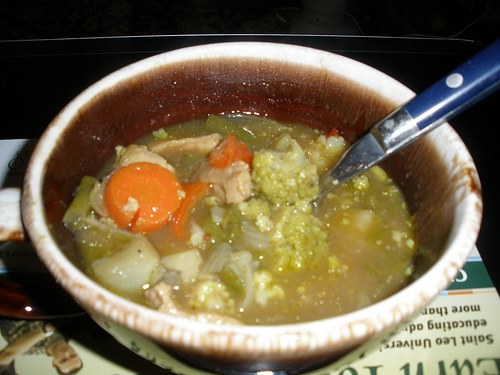Describe a humorous story in which this bowl of soup becomes sentient. One day, in a bustling kitchen, a bowl of soup suddenly came to life! Startled but curious, it looked around and saw the chefs working. Deciding to see the world, the soup bowl quietly crawled off the counter and started exploring. It slid under tables, dodged feet, and even hitched a ride on a serving trolley. Along the way, it met a mischievous bread roll and a charismatic cheese wedge. Together, they hatched a plan to escape the kitchen and see the world beyond. After numerous hilarious mishaps – including almost being eaten, slipping on olive oil, and a dramatic chase by the head chef – the trio finally made it out. They set up home in a cozy corner of the garden, where they lived happily, sharing stories and dreaming about their next great adventure. 